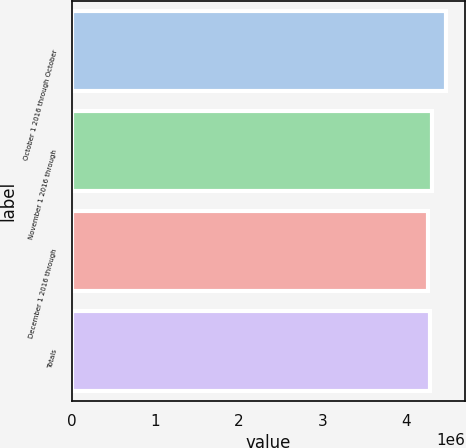<chart> <loc_0><loc_0><loc_500><loc_500><bar_chart><fcel>October 1 2016 through October<fcel>November 1 2016 through<fcel>December 1 2016 through<fcel>Totals<nl><fcel>4.47789e+06<fcel>4.30377e+06<fcel>4.26024e+06<fcel>4.28201e+06<nl></chart> 